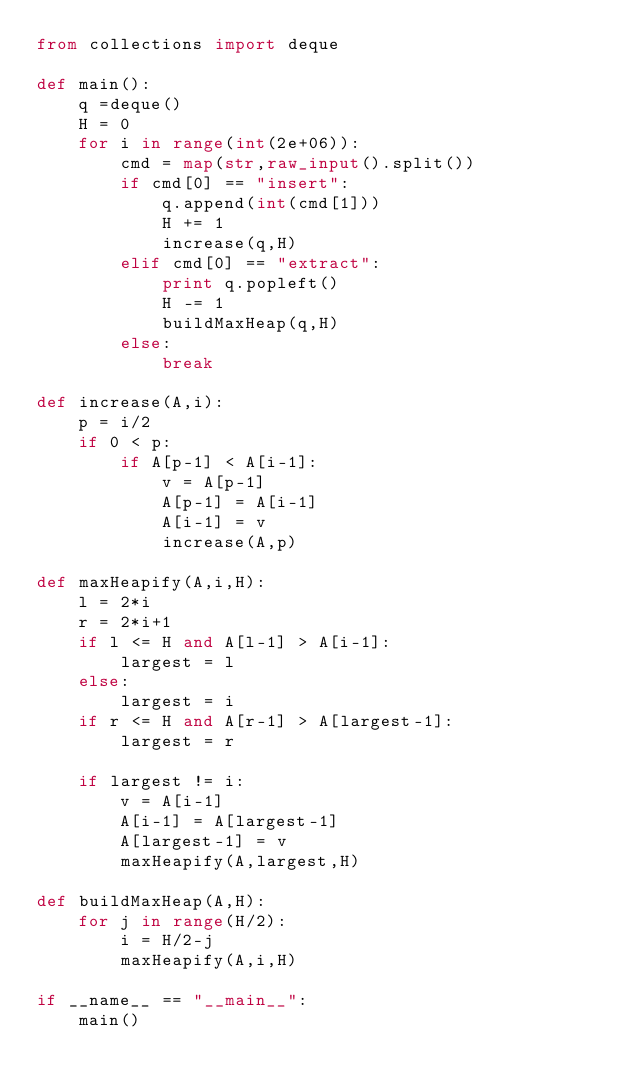Convert code to text. <code><loc_0><loc_0><loc_500><loc_500><_Python_>from collections import deque

def main():
    q =deque()
    H = 0
    for i in range(int(2e+06)):
        cmd = map(str,raw_input().split())
        if cmd[0] == "insert":
            q.append(int(cmd[1]))
            H += 1
            increase(q,H)
        elif cmd[0] == "extract":
            print q.popleft()
            H -= 1
            buildMaxHeap(q,H)
        else:
            break

def increase(A,i):
    p = i/2
    if 0 < p:
        if A[p-1] < A[i-1]:
            v = A[p-1]
            A[p-1] = A[i-1]
            A[i-1] = v
            increase(A,p)
            
def maxHeapify(A,i,H):
    l = 2*i
    r = 2*i+1
    if l <= H and A[l-1] > A[i-1]:
        largest = l
    else:
        largest = i
    if r <= H and A[r-1] > A[largest-1]:
        largest = r

    if largest != i:
        v = A[i-1]
        A[i-1] = A[largest-1]
        A[largest-1] = v
        maxHeapify(A,largest,H)

def buildMaxHeap(A,H):
    for j in range(H/2):
        i = H/2-j
        maxHeapify(A,i,H)

if __name__ == "__main__":
    main()</code> 